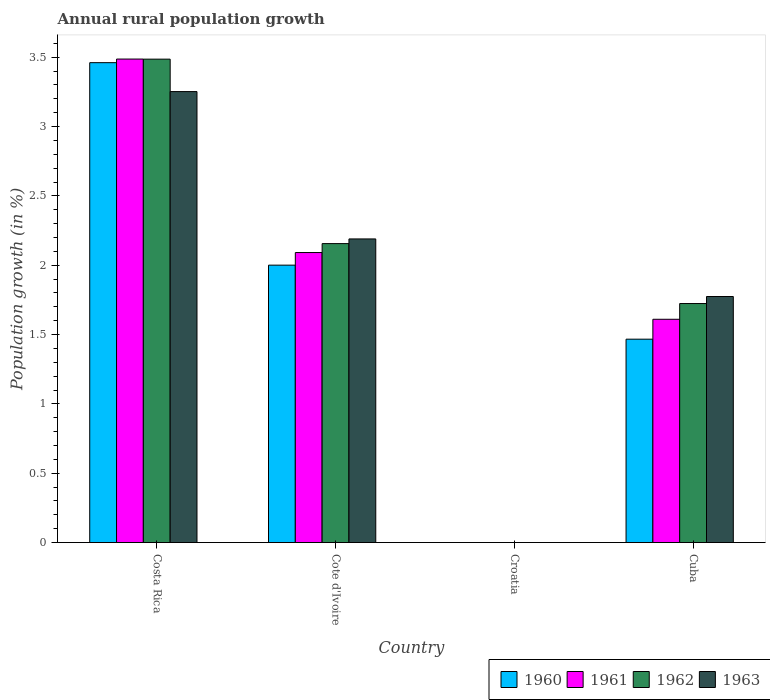Are the number of bars per tick equal to the number of legend labels?
Make the answer very short. No. How many bars are there on the 4th tick from the right?
Keep it short and to the point. 4. What is the label of the 4th group of bars from the left?
Make the answer very short. Cuba. In how many cases, is the number of bars for a given country not equal to the number of legend labels?
Ensure brevity in your answer.  1. What is the percentage of rural population growth in 1960 in Cote d'Ivoire?
Provide a short and direct response. 2. Across all countries, what is the maximum percentage of rural population growth in 1961?
Your answer should be very brief. 3.49. What is the total percentage of rural population growth in 1960 in the graph?
Provide a short and direct response. 6.93. What is the difference between the percentage of rural population growth in 1960 in Cote d'Ivoire and that in Cuba?
Your answer should be compact. 0.53. What is the difference between the percentage of rural population growth in 1962 in Cuba and the percentage of rural population growth in 1963 in Costa Rica?
Keep it short and to the point. -1.53. What is the average percentage of rural population growth in 1962 per country?
Your answer should be compact. 1.84. What is the difference between the percentage of rural population growth of/in 1962 and percentage of rural population growth of/in 1960 in Costa Rica?
Offer a very short reply. 0.03. What is the ratio of the percentage of rural population growth in 1962 in Costa Rica to that in Cote d'Ivoire?
Your answer should be very brief. 1.62. Is the difference between the percentage of rural population growth in 1962 in Cote d'Ivoire and Cuba greater than the difference between the percentage of rural population growth in 1960 in Cote d'Ivoire and Cuba?
Offer a very short reply. No. What is the difference between the highest and the second highest percentage of rural population growth in 1963?
Ensure brevity in your answer.  -0.42. What is the difference between the highest and the lowest percentage of rural population growth in 1962?
Your response must be concise. 3.49. Are all the bars in the graph horizontal?
Provide a succinct answer. No. How many countries are there in the graph?
Your answer should be compact. 4. Are the values on the major ticks of Y-axis written in scientific E-notation?
Make the answer very short. No. Does the graph contain any zero values?
Your response must be concise. Yes. How many legend labels are there?
Your response must be concise. 4. How are the legend labels stacked?
Your answer should be compact. Horizontal. What is the title of the graph?
Provide a short and direct response. Annual rural population growth. Does "2015" appear as one of the legend labels in the graph?
Your response must be concise. No. What is the label or title of the X-axis?
Provide a short and direct response. Country. What is the label or title of the Y-axis?
Your answer should be compact. Population growth (in %). What is the Population growth (in %) of 1960 in Costa Rica?
Offer a terse response. 3.46. What is the Population growth (in %) of 1961 in Costa Rica?
Keep it short and to the point. 3.49. What is the Population growth (in %) of 1962 in Costa Rica?
Ensure brevity in your answer.  3.49. What is the Population growth (in %) in 1963 in Costa Rica?
Ensure brevity in your answer.  3.25. What is the Population growth (in %) in 1960 in Cote d'Ivoire?
Your answer should be compact. 2. What is the Population growth (in %) of 1961 in Cote d'Ivoire?
Your answer should be very brief. 2.09. What is the Population growth (in %) of 1962 in Cote d'Ivoire?
Your answer should be compact. 2.16. What is the Population growth (in %) of 1963 in Cote d'Ivoire?
Offer a very short reply. 2.19. What is the Population growth (in %) of 1960 in Croatia?
Your answer should be very brief. 0. What is the Population growth (in %) of 1961 in Croatia?
Your answer should be very brief. 0. What is the Population growth (in %) in 1963 in Croatia?
Your answer should be very brief. 0. What is the Population growth (in %) of 1960 in Cuba?
Ensure brevity in your answer.  1.47. What is the Population growth (in %) in 1961 in Cuba?
Ensure brevity in your answer.  1.61. What is the Population growth (in %) of 1962 in Cuba?
Give a very brief answer. 1.72. What is the Population growth (in %) in 1963 in Cuba?
Provide a succinct answer. 1.77. Across all countries, what is the maximum Population growth (in %) in 1960?
Your response must be concise. 3.46. Across all countries, what is the maximum Population growth (in %) in 1961?
Provide a succinct answer. 3.49. Across all countries, what is the maximum Population growth (in %) of 1962?
Offer a very short reply. 3.49. Across all countries, what is the maximum Population growth (in %) in 1963?
Your response must be concise. 3.25. Across all countries, what is the minimum Population growth (in %) of 1961?
Give a very brief answer. 0. Across all countries, what is the minimum Population growth (in %) in 1962?
Provide a short and direct response. 0. What is the total Population growth (in %) in 1960 in the graph?
Your response must be concise. 6.93. What is the total Population growth (in %) in 1961 in the graph?
Offer a terse response. 7.19. What is the total Population growth (in %) of 1962 in the graph?
Your answer should be compact. 7.37. What is the total Population growth (in %) of 1963 in the graph?
Your answer should be very brief. 7.22. What is the difference between the Population growth (in %) in 1960 in Costa Rica and that in Cote d'Ivoire?
Your answer should be compact. 1.46. What is the difference between the Population growth (in %) of 1961 in Costa Rica and that in Cote d'Ivoire?
Your answer should be compact. 1.4. What is the difference between the Population growth (in %) of 1962 in Costa Rica and that in Cote d'Ivoire?
Provide a short and direct response. 1.33. What is the difference between the Population growth (in %) in 1963 in Costa Rica and that in Cote d'Ivoire?
Your answer should be compact. 1.06. What is the difference between the Population growth (in %) in 1960 in Costa Rica and that in Cuba?
Make the answer very short. 1.99. What is the difference between the Population growth (in %) in 1961 in Costa Rica and that in Cuba?
Give a very brief answer. 1.88. What is the difference between the Population growth (in %) of 1962 in Costa Rica and that in Cuba?
Provide a succinct answer. 1.76. What is the difference between the Population growth (in %) of 1963 in Costa Rica and that in Cuba?
Provide a succinct answer. 1.48. What is the difference between the Population growth (in %) of 1960 in Cote d'Ivoire and that in Cuba?
Your response must be concise. 0.53. What is the difference between the Population growth (in %) in 1961 in Cote d'Ivoire and that in Cuba?
Give a very brief answer. 0.48. What is the difference between the Population growth (in %) of 1962 in Cote d'Ivoire and that in Cuba?
Provide a succinct answer. 0.43. What is the difference between the Population growth (in %) in 1963 in Cote d'Ivoire and that in Cuba?
Your answer should be very brief. 0.42. What is the difference between the Population growth (in %) of 1960 in Costa Rica and the Population growth (in %) of 1961 in Cote d'Ivoire?
Keep it short and to the point. 1.37. What is the difference between the Population growth (in %) of 1960 in Costa Rica and the Population growth (in %) of 1962 in Cote d'Ivoire?
Make the answer very short. 1.3. What is the difference between the Population growth (in %) of 1960 in Costa Rica and the Population growth (in %) of 1963 in Cote d'Ivoire?
Provide a succinct answer. 1.27. What is the difference between the Population growth (in %) of 1961 in Costa Rica and the Population growth (in %) of 1962 in Cote d'Ivoire?
Provide a short and direct response. 1.33. What is the difference between the Population growth (in %) in 1961 in Costa Rica and the Population growth (in %) in 1963 in Cote d'Ivoire?
Your answer should be very brief. 1.3. What is the difference between the Population growth (in %) in 1962 in Costa Rica and the Population growth (in %) in 1963 in Cote d'Ivoire?
Offer a terse response. 1.3. What is the difference between the Population growth (in %) in 1960 in Costa Rica and the Population growth (in %) in 1961 in Cuba?
Provide a short and direct response. 1.85. What is the difference between the Population growth (in %) in 1960 in Costa Rica and the Population growth (in %) in 1962 in Cuba?
Give a very brief answer. 1.74. What is the difference between the Population growth (in %) in 1960 in Costa Rica and the Population growth (in %) in 1963 in Cuba?
Offer a terse response. 1.69. What is the difference between the Population growth (in %) of 1961 in Costa Rica and the Population growth (in %) of 1962 in Cuba?
Your answer should be very brief. 1.76. What is the difference between the Population growth (in %) of 1961 in Costa Rica and the Population growth (in %) of 1963 in Cuba?
Offer a terse response. 1.71. What is the difference between the Population growth (in %) of 1962 in Costa Rica and the Population growth (in %) of 1963 in Cuba?
Ensure brevity in your answer.  1.71. What is the difference between the Population growth (in %) in 1960 in Cote d'Ivoire and the Population growth (in %) in 1961 in Cuba?
Your answer should be compact. 0.39. What is the difference between the Population growth (in %) of 1960 in Cote d'Ivoire and the Population growth (in %) of 1962 in Cuba?
Keep it short and to the point. 0.28. What is the difference between the Population growth (in %) in 1960 in Cote d'Ivoire and the Population growth (in %) in 1963 in Cuba?
Provide a succinct answer. 0.23. What is the difference between the Population growth (in %) of 1961 in Cote d'Ivoire and the Population growth (in %) of 1962 in Cuba?
Make the answer very short. 0.37. What is the difference between the Population growth (in %) in 1961 in Cote d'Ivoire and the Population growth (in %) in 1963 in Cuba?
Give a very brief answer. 0.32. What is the difference between the Population growth (in %) of 1962 in Cote d'Ivoire and the Population growth (in %) of 1963 in Cuba?
Provide a short and direct response. 0.38. What is the average Population growth (in %) of 1960 per country?
Give a very brief answer. 1.73. What is the average Population growth (in %) in 1961 per country?
Your response must be concise. 1.8. What is the average Population growth (in %) in 1962 per country?
Your response must be concise. 1.84. What is the average Population growth (in %) in 1963 per country?
Your answer should be very brief. 1.8. What is the difference between the Population growth (in %) of 1960 and Population growth (in %) of 1961 in Costa Rica?
Provide a succinct answer. -0.03. What is the difference between the Population growth (in %) in 1960 and Population growth (in %) in 1962 in Costa Rica?
Your answer should be very brief. -0.03. What is the difference between the Population growth (in %) of 1960 and Population growth (in %) of 1963 in Costa Rica?
Provide a short and direct response. 0.21. What is the difference between the Population growth (in %) in 1961 and Population growth (in %) in 1962 in Costa Rica?
Your answer should be very brief. 0. What is the difference between the Population growth (in %) in 1961 and Population growth (in %) in 1963 in Costa Rica?
Make the answer very short. 0.23. What is the difference between the Population growth (in %) in 1962 and Population growth (in %) in 1963 in Costa Rica?
Your response must be concise. 0.23. What is the difference between the Population growth (in %) in 1960 and Population growth (in %) in 1961 in Cote d'Ivoire?
Ensure brevity in your answer.  -0.09. What is the difference between the Population growth (in %) in 1960 and Population growth (in %) in 1962 in Cote d'Ivoire?
Ensure brevity in your answer.  -0.16. What is the difference between the Population growth (in %) in 1960 and Population growth (in %) in 1963 in Cote d'Ivoire?
Make the answer very short. -0.19. What is the difference between the Population growth (in %) in 1961 and Population growth (in %) in 1962 in Cote d'Ivoire?
Your answer should be compact. -0.06. What is the difference between the Population growth (in %) of 1961 and Population growth (in %) of 1963 in Cote d'Ivoire?
Provide a succinct answer. -0.1. What is the difference between the Population growth (in %) of 1962 and Population growth (in %) of 1963 in Cote d'Ivoire?
Give a very brief answer. -0.03. What is the difference between the Population growth (in %) of 1960 and Population growth (in %) of 1961 in Cuba?
Your response must be concise. -0.14. What is the difference between the Population growth (in %) of 1960 and Population growth (in %) of 1962 in Cuba?
Keep it short and to the point. -0.26. What is the difference between the Population growth (in %) in 1960 and Population growth (in %) in 1963 in Cuba?
Ensure brevity in your answer.  -0.31. What is the difference between the Population growth (in %) in 1961 and Population growth (in %) in 1962 in Cuba?
Your answer should be very brief. -0.11. What is the difference between the Population growth (in %) of 1961 and Population growth (in %) of 1963 in Cuba?
Give a very brief answer. -0.16. What is the difference between the Population growth (in %) of 1962 and Population growth (in %) of 1963 in Cuba?
Your response must be concise. -0.05. What is the ratio of the Population growth (in %) of 1960 in Costa Rica to that in Cote d'Ivoire?
Make the answer very short. 1.73. What is the ratio of the Population growth (in %) in 1961 in Costa Rica to that in Cote d'Ivoire?
Offer a terse response. 1.67. What is the ratio of the Population growth (in %) of 1962 in Costa Rica to that in Cote d'Ivoire?
Provide a succinct answer. 1.62. What is the ratio of the Population growth (in %) of 1963 in Costa Rica to that in Cote d'Ivoire?
Your response must be concise. 1.49. What is the ratio of the Population growth (in %) of 1960 in Costa Rica to that in Cuba?
Keep it short and to the point. 2.36. What is the ratio of the Population growth (in %) in 1961 in Costa Rica to that in Cuba?
Ensure brevity in your answer.  2.17. What is the ratio of the Population growth (in %) of 1962 in Costa Rica to that in Cuba?
Your answer should be very brief. 2.02. What is the ratio of the Population growth (in %) in 1963 in Costa Rica to that in Cuba?
Ensure brevity in your answer.  1.83. What is the ratio of the Population growth (in %) in 1960 in Cote d'Ivoire to that in Cuba?
Provide a short and direct response. 1.36. What is the ratio of the Population growth (in %) of 1961 in Cote d'Ivoire to that in Cuba?
Keep it short and to the point. 1.3. What is the ratio of the Population growth (in %) of 1962 in Cote d'Ivoire to that in Cuba?
Your answer should be compact. 1.25. What is the ratio of the Population growth (in %) in 1963 in Cote d'Ivoire to that in Cuba?
Your answer should be very brief. 1.23. What is the difference between the highest and the second highest Population growth (in %) of 1960?
Ensure brevity in your answer.  1.46. What is the difference between the highest and the second highest Population growth (in %) of 1961?
Make the answer very short. 1.4. What is the difference between the highest and the second highest Population growth (in %) in 1962?
Ensure brevity in your answer.  1.33. What is the difference between the highest and the second highest Population growth (in %) of 1963?
Your response must be concise. 1.06. What is the difference between the highest and the lowest Population growth (in %) in 1960?
Give a very brief answer. 3.46. What is the difference between the highest and the lowest Population growth (in %) of 1961?
Offer a very short reply. 3.49. What is the difference between the highest and the lowest Population growth (in %) in 1962?
Your answer should be compact. 3.49. What is the difference between the highest and the lowest Population growth (in %) in 1963?
Provide a short and direct response. 3.25. 